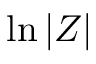<formula> <loc_0><loc_0><loc_500><loc_500>\ln { | Z | }</formula> 